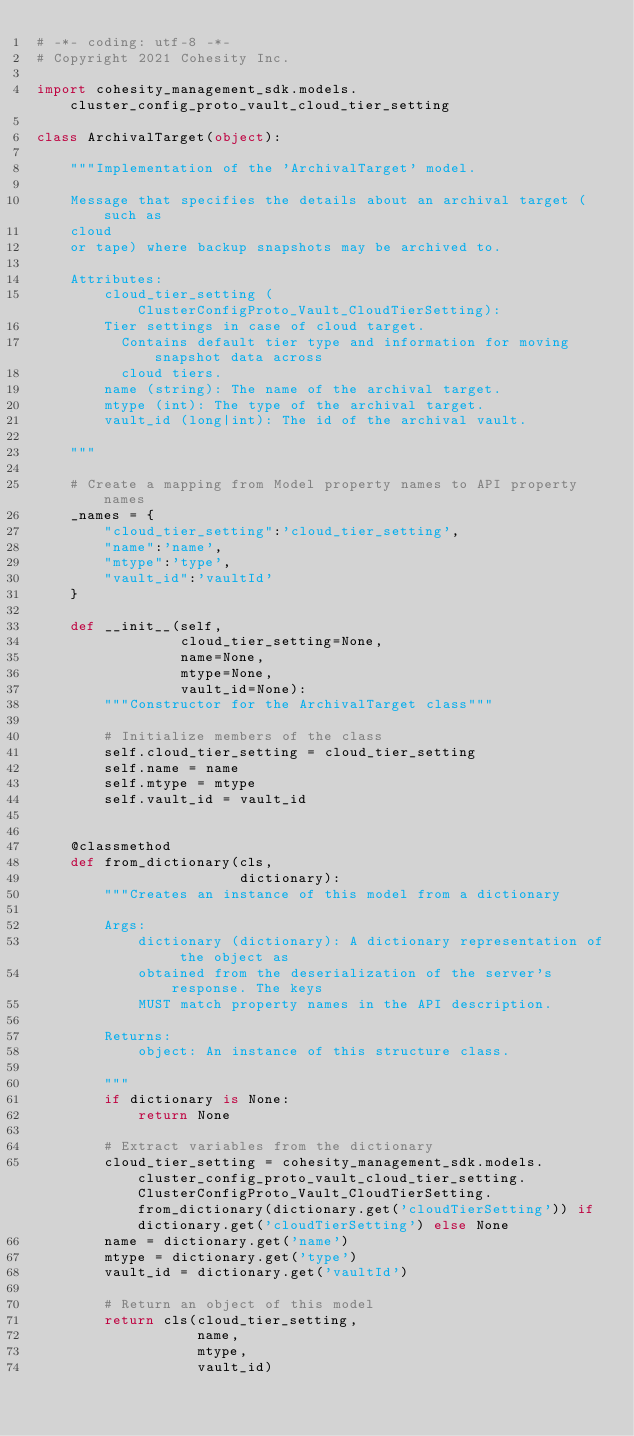Convert code to text. <code><loc_0><loc_0><loc_500><loc_500><_Python_># -*- coding: utf-8 -*-
# Copyright 2021 Cohesity Inc.

import cohesity_management_sdk.models.cluster_config_proto_vault_cloud_tier_setting

class ArchivalTarget(object):

    """Implementation of the 'ArchivalTarget' model.

    Message that specifies the details about an archival target (such as
    cloud
    or tape) where backup snapshots may be archived to.

    Attributes:
        cloud_tier_setting (ClusterConfigProto_Vault_CloudTierSetting):
        Tier settings in case of cloud target.
          Contains default tier type and information for moving snapshot data across
          cloud tiers.
        name (string): The name of the archival target.
        mtype (int): The type of the archival target.
        vault_id (long|int): The id of the archival vault.

    """

    # Create a mapping from Model property names to API property names
    _names = {
        "cloud_tier_setting":'cloud_tier_setting',
        "name":'name',
        "mtype":'type',
        "vault_id":'vaultId'
    }

    def __init__(self,
                 cloud_tier_setting=None,
                 name=None,
                 mtype=None,
                 vault_id=None):
        """Constructor for the ArchivalTarget class"""

        # Initialize members of the class
        self.cloud_tier_setting = cloud_tier_setting
        self.name = name
        self.mtype = mtype
        self.vault_id = vault_id


    @classmethod
    def from_dictionary(cls,
                        dictionary):
        """Creates an instance of this model from a dictionary

        Args:
            dictionary (dictionary): A dictionary representation of the object as
            obtained from the deserialization of the server's response. The keys
            MUST match property names in the API description.

        Returns:
            object: An instance of this structure class.

        """
        if dictionary is None:
            return None

        # Extract variables from the dictionary
        cloud_tier_setting = cohesity_management_sdk.models.cluster_config_proto_vault_cloud_tier_setting.ClusterConfigProto_Vault_CloudTierSetting.from_dictionary(dictionary.get('cloudTierSetting')) if dictionary.get('cloudTierSetting') else None
        name = dictionary.get('name')
        mtype = dictionary.get('type')
        vault_id = dictionary.get('vaultId')

        # Return an object of this model
        return cls(cloud_tier_setting,
                   name,
                   mtype,
                   vault_id)


</code> 